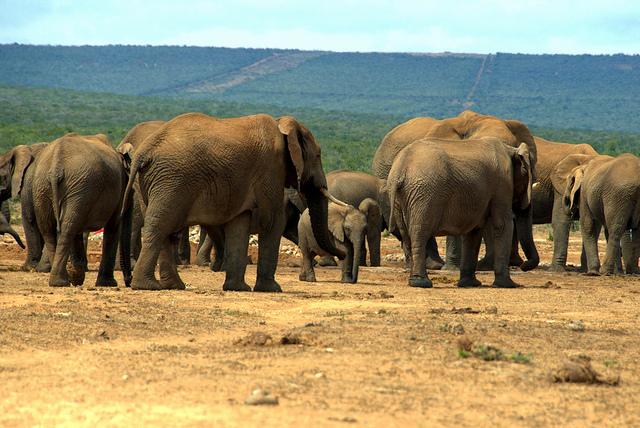Is the ground wet?
Quick response, please. No. Is it being guarded?
Concise answer only. Yes. Why is the immature one in the middle?
Give a very brief answer. Protection. 